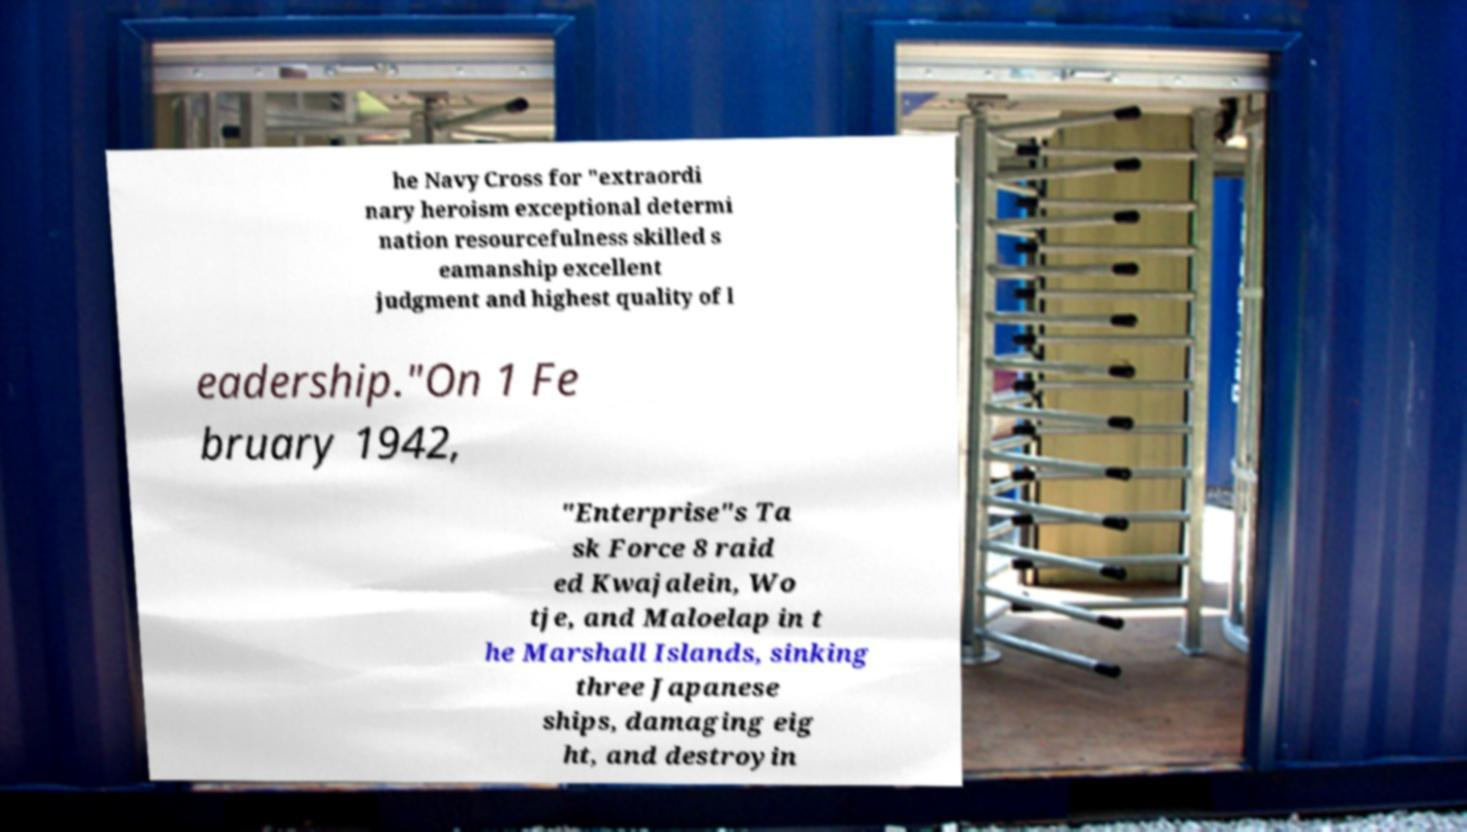Can you read and provide the text displayed in the image?This photo seems to have some interesting text. Can you extract and type it out for me? he Navy Cross for "extraordi nary heroism exceptional determi nation resourcefulness skilled s eamanship excellent judgment and highest quality of l eadership."On 1 Fe bruary 1942, "Enterprise"s Ta sk Force 8 raid ed Kwajalein, Wo tje, and Maloelap in t he Marshall Islands, sinking three Japanese ships, damaging eig ht, and destroyin 